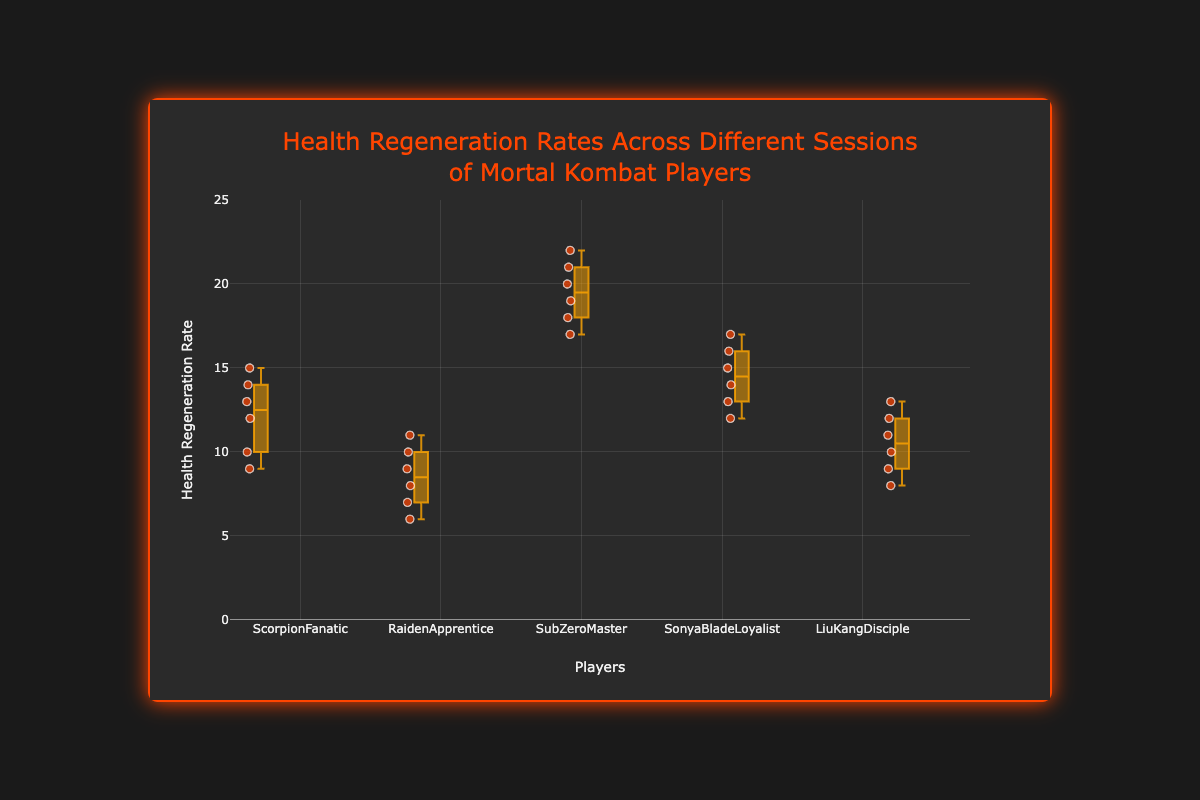What's the title of the figure? The title is prominently displayed at the top of the figure. It reads "Health Regeneration Rates Across Different Sessions of Mortal Kombat Players."
Answer: Health Regeneration Rates Across Different Sessions of Mortal Kombat Players Which player has the highest median health regeneration rate? To identify the player with the highest median, look at the central line within each box. SubZeroMaster’s box plot has the highest central line.
Answer: SubZeroMaster How does the interquartile range (IQR) of LiuKangDisciple compare to that of RaidenApprentice? The IQR is the difference between the 75th percentile (top of the box) and the 25th percentile (bottom of the box). The IQR for LiuKangDisciple covers more range compared to RaidenApprentice based on the bigger height of LiuKangDisciple's box.
Answer: LiuKangDisciple has a larger IQR than RaidenApprentice What's the maximum health regeneration rate recorded for SonyaBladeLoyalist? The maximum rate is shown as a point above the top whisker of the box plot. For SonyaBladeLoyalist, this maximum rate is 17.
Answer: 17 Among all players, who has the smallest range of health regeneration rates? The range is the difference between the max and min values. The smallest height from the top to the bottom whisker appears for RaidenApprentice.
Answer: RaidenApprentice Which player has the most consistent health regeneration rates? Consistency can be measured by the range (difference between the highest and lowest values). The smallest range is with RaidenApprentice.
Answer: RaidenApprentice Compare the median health regeneration rates of ScorpionFanatic to that of LiuKangDisciple. Look at the central lines of both players' box plots. ScorpionFanatic’s median line is slightly higher than LiuKangDisciple’s.
Answer: ScorpionFanatic's median is higher What is the average of the maximum health regeneration rates for ScorpionFanatic and SubZeroMaster? ScorpionFanatic’s maximum is 15, and SubZeroMaster’s maximum is 22. The average is calculated as (15 + 22) / 2 = 18.5.
Answer: 18.5 